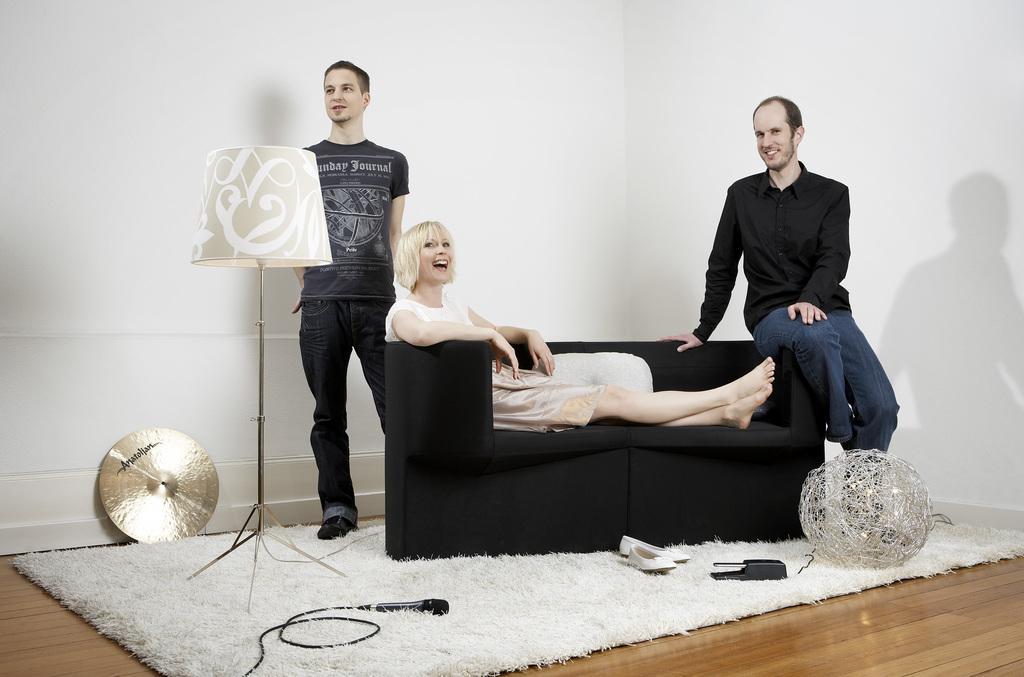Could you give a brief overview of what you see in this image? There is a lady sitting on a sofa behind her there is a man sitting and at one edge and on other end there is a man standing in front of lamp on a carpet. 